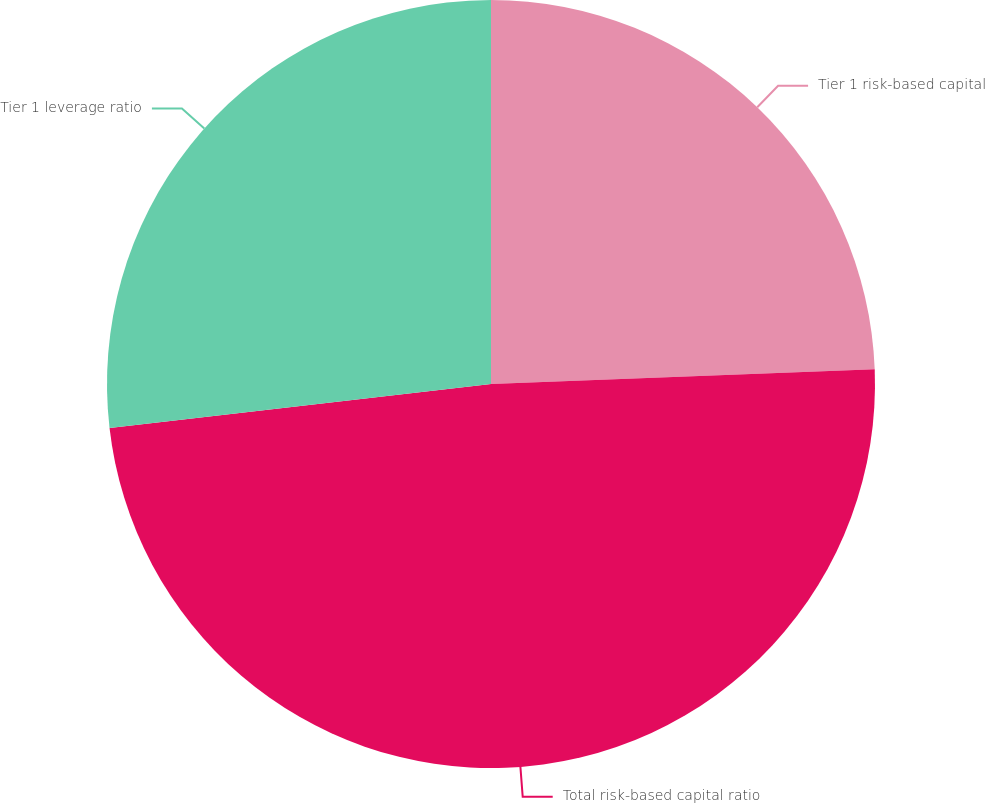<chart> <loc_0><loc_0><loc_500><loc_500><pie_chart><fcel>Tier 1 risk-based capital<fcel>Total risk-based capital ratio<fcel>Tier 1 leverage ratio<nl><fcel>24.39%<fcel>48.78%<fcel>26.83%<nl></chart> 